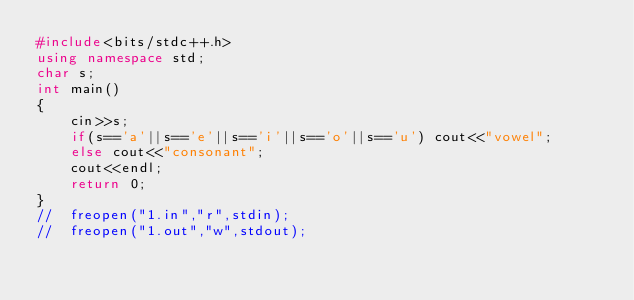Convert code to text. <code><loc_0><loc_0><loc_500><loc_500><_C++_>#include<bits/stdc++.h>
using namespace std;
char s;
int main()
{
    cin>>s;
    if(s=='a'||s=='e'||s=='i'||s=='o'||s=='u') cout<<"vowel";
    else cout<<"consonant";
    cout<<endl;
    return 0;
}
//	freopen("1.in","r",stdin);
//  freopen("1.out","w",stdout);</code> 